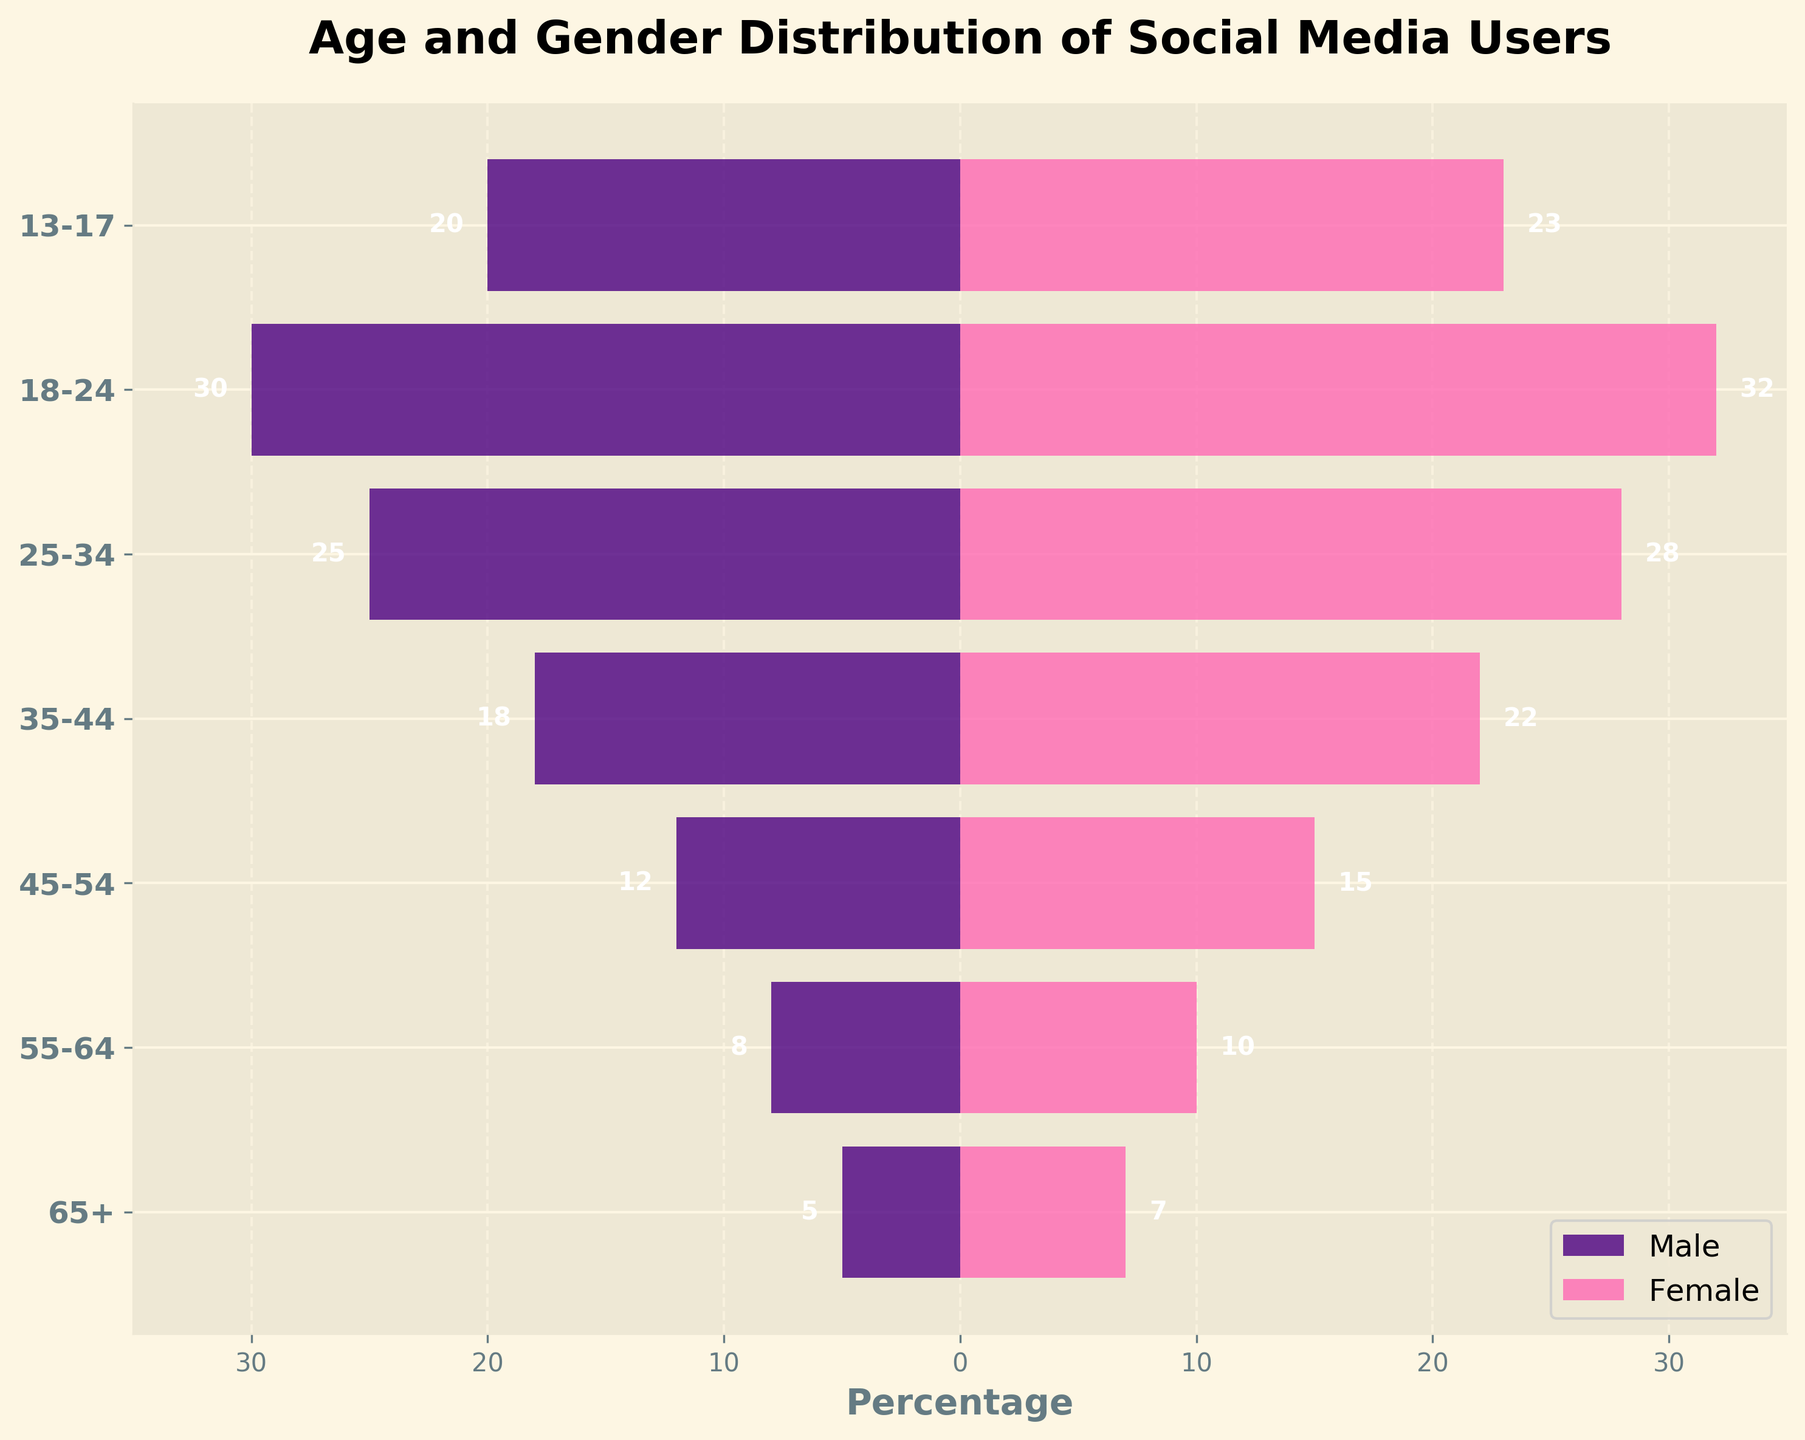What is the title of the plot? The title is found at the top of the figure and typically describes what the figure is about. In this case, the title reads "Age and Gender Distribution of Social Media Users."
Answer: Age and Gender Distribution of Social Media Users In which age group do males have the highest percentage? To find this, look for the bar representing the male population that extends the furthest to the left. The age group "18-24" has the highest male percentage with a value of -30.
Answer: 18-24 How many age groups are represented in the plot? Each horizontal bar represents one age group. By counting the bars, we can see there are seven age groups.
Answer: 7 Which age group has the smallest difference between male and female percentages? To determine this, find the absolute difference between male and female percentages for each age group. The age group "65+" has the smallest difference (7 - (-5) = 12).
Answer: 65+ What is the total percentage of female users from all age groups combined? Sum the values for females across all age groups: 7 + 10 + 15 + 22 + 28 + 32 + 23 = 137.
Answer: 137 What's the difference between the total male and female percentages in the "35-44" age group? Subtract the male percentage from the female percentage for the "35-44" age group: 22 - (-18) = 40.
Answer: 40 Which gender has a higher percentage in the "55-64" age group? Compare the values for males and females in the "55-64" age group. For males, it is -8 and for females, it is 10. So, the female percentage is higher.
Answer: Female What's the total percentage difference between males and females in the "13-17" age group? Calculate the absolute difference in percentages for the "13-17" age group: 23 - (-20) = 43.
Answer: 43 In which age group is the gender ratio most balanced? Look for the smallest absolute difference between male and female percentages. The age group "65+" with a difference of 12 (7 - (-5)) is the most balanced.
Answer: 65+ Which age group has the least number of female users? Locate the shortest bar on the right side (female) of the plot. The "65+" age group has the smallest female percentage at 7.
Answer: 65+ 